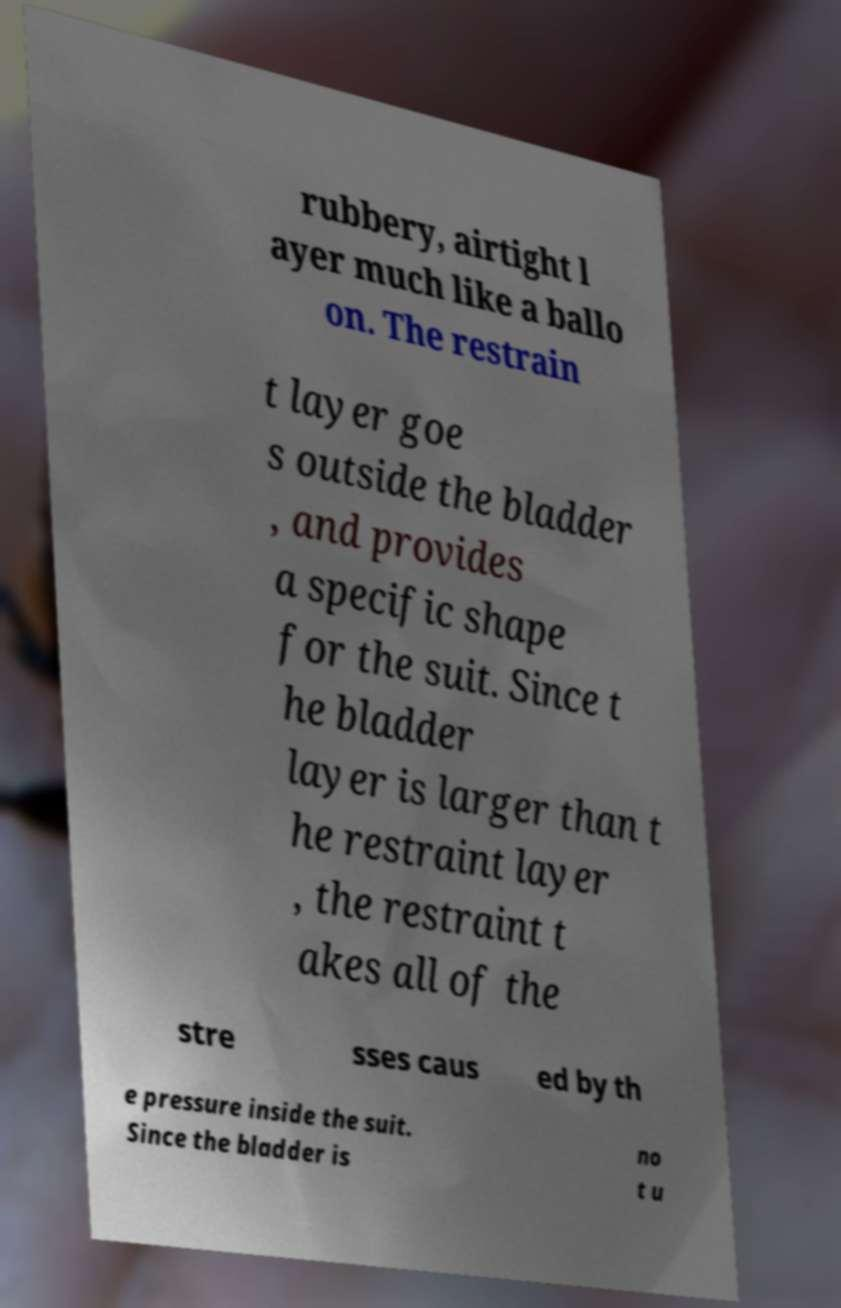For documentation purposes, I need the text within this image transcribed. Could you provide that? rubbery, airtight l ayer much like a ballo on. The restrain t layer goe s outside the bladder , and provides a specific shape for the suit. Since t he bladder layer is larger than t he restraint layer , the restraint t akes all of the stre sses caus ed by th e pressure inside the suit. Since the bladder is no t u 